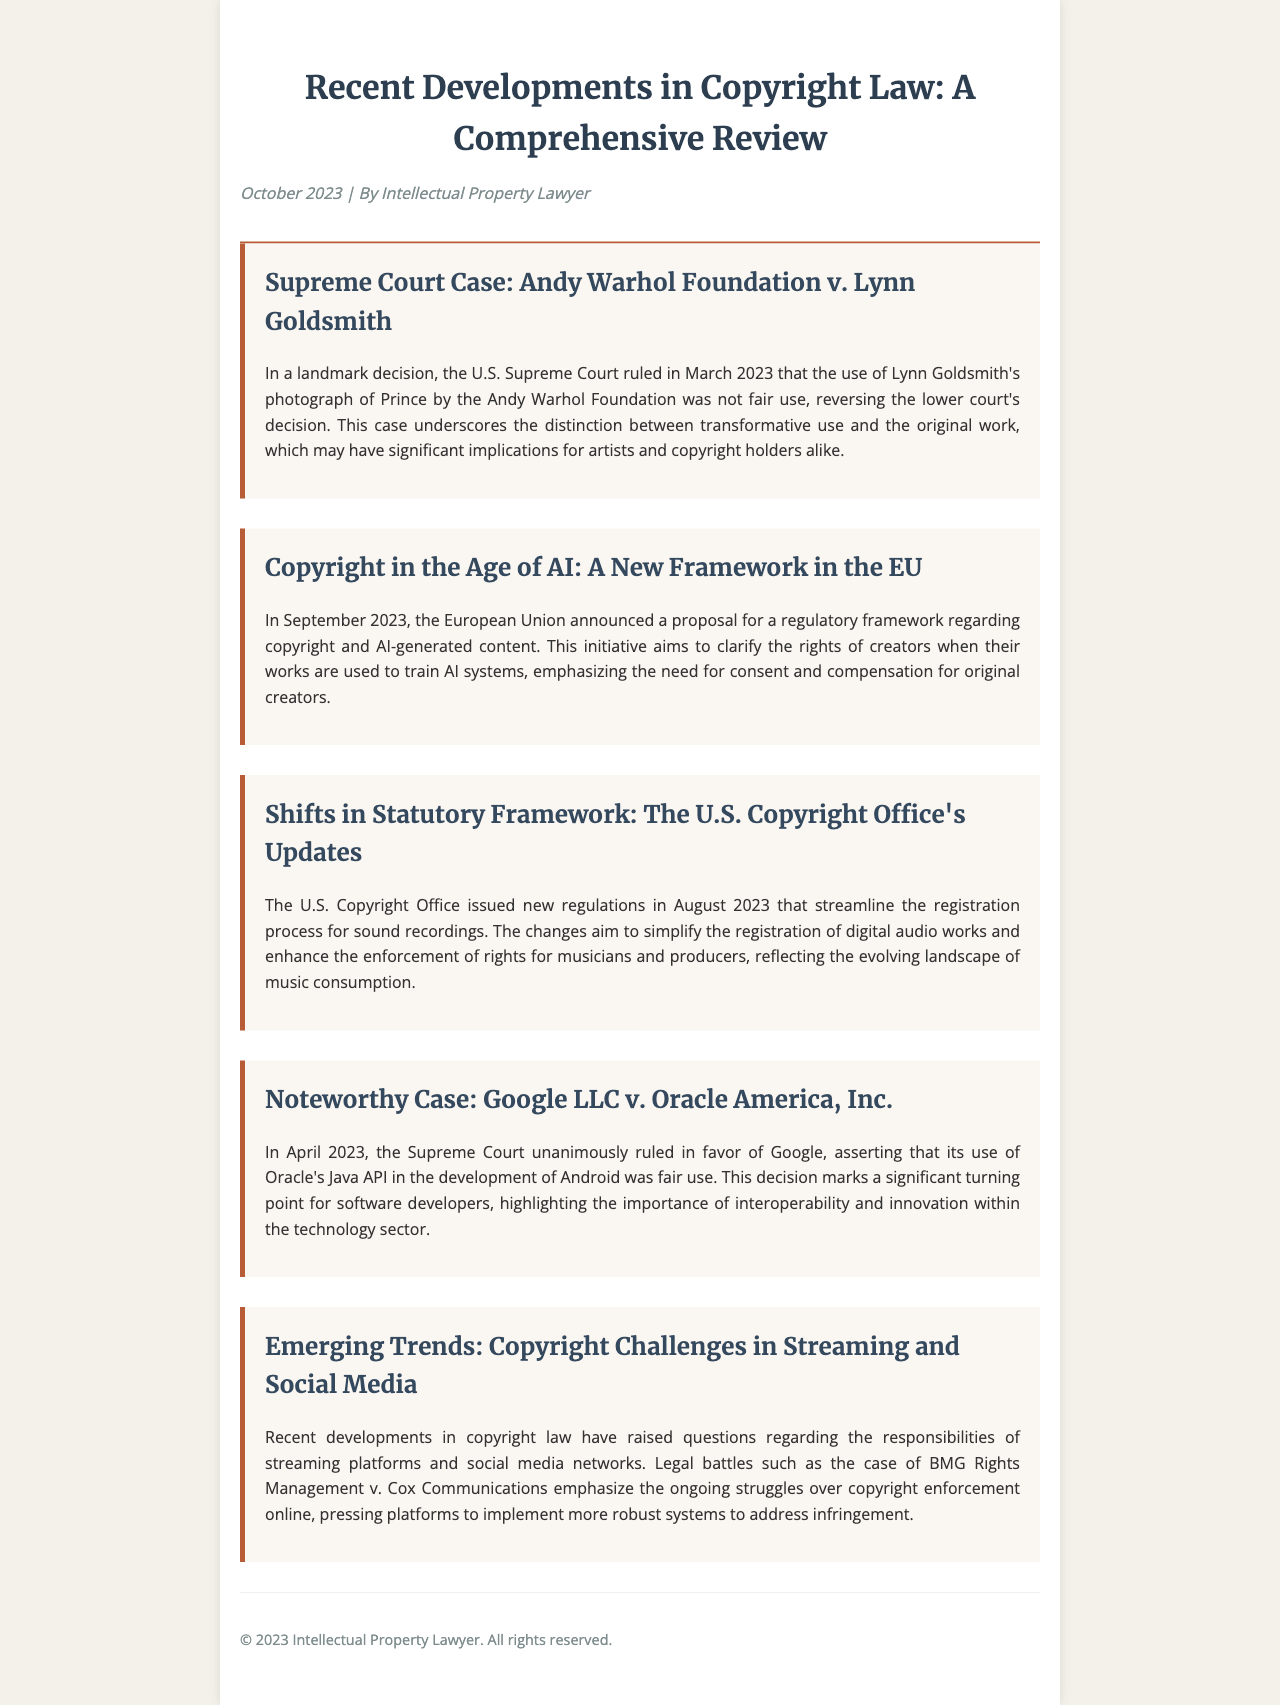What was the decision in the Andy Warhol Foundation case? The U.S. Supreme Court ruled that the use of Lynn Goldsmith's photograph was not fair use, reversing the lower court's decision.
Answer: Not fair use What new regulatory framework was announced by the EU in September 2023? The European Union announced a proposal for a regulatory framework regarding copyright and AI-generated content.
Answer: AI-generated content When were the U.S. Copyright Office's new regulations issued? The U.S. Copyright Office issued new regulations in August 2023.
Answer: August 2023 What was the outcome of Google LLC v. Oracle America, Inc.? The Supreme Court ruled in favor of Google, asserting that its use of Oracle's Java API was fair use.
Answer: Fair use What ongoing struggles are highlighted in the context of streaming platforms? Legal battles such as BMG Rights Management v. Cox Communications emphasize copyright enforcement struggles online.
Answer: Copyright enforcement Which artist's photograph was used by the Andy Warhol Foundation? Lynn Goldsmith's photograph of Prince was used.
Answer: Lynn Goldsmith What significant themes are touched upon in the section about copyright challenges? The section discusses responsibilities of streaming platforms and social media networks regarding copyright.
Answer: Responsibilities of platforms In what month and year did the Supreme Court rule in the Andy Warhol Foundation case? The ruling was made in March 2023.
Answer: March 2023 